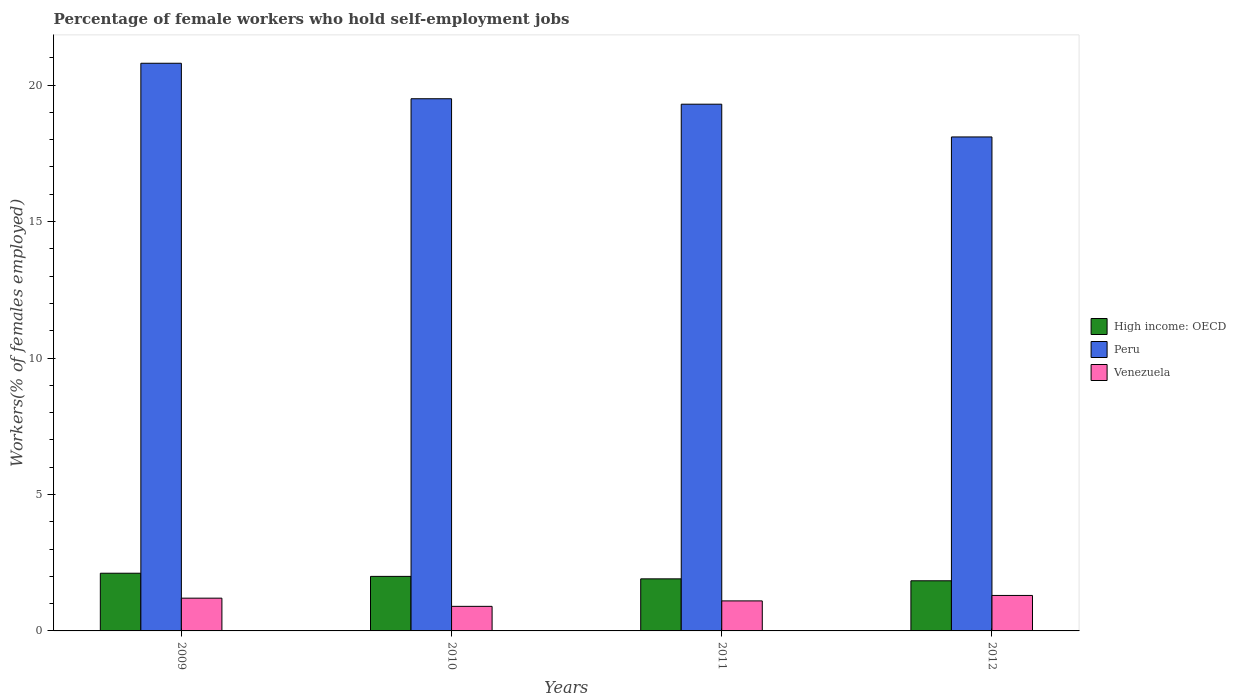Are the number of bars per tick equal to the number of legend labels?
Offer a terse response. Yes. Are the number of bars on each tick of the X-axis equal?
Offer a very short reply. Yes. How many bars are there on the 1st tick from the left?
Provide a succinct answer. 3. What is the percentage of self-employed female workers in High income: OECD in 2012?
Ensure brevity in your answer.  1.84. Across all years, what is the maximum percentage of self-employed female workers in Venezuela?
Provide a succinct answer. 1.3. Across all years, what is the minimum percentage of self-employed female workers in Venezuela?
Ensure brevity in your answer.  0.9. What is the total percentage of self-employed female workers in High income: OECD in the graph?
Your answer should be very brief. 7.86. What is the difference between the percentage of self-employed female workers in Peru in 2009 and that in 2012?
Your response must be concise. 2.7. What is the difference between the percentage of self-employed female workers in Venezuela in 2010 and the percentage of self-employed female workers in High income: OECD in 2012?
Ensure brevity in your answer.  -0.94. What is the average percentage of self-employed female workers in High income: OECD per year?
Provide a succinct answer. 1.96. In the year 2009, what is the difference between the percentage of self-employed female workers in High income: OECD and percentage of self-employed female workers in Venezuela?
Offer a terse response. 0.91. What is the ratio of the percentage of self-employed female workers in Peru in 2009 to that in 2011?
Provide a succinct answer. 1.08. Is the percentage of self-employed female workers in Venezuela in 2009 less than that in 2011?
Offer a terse response. No. Is the difference between the percentage of self-employed female workers in High income: OECD in 2009 and 2012 greater than the difference between the percentage of self-employed female workers in Venezuela in 2009 and 2012?
Your response must be concise. Yes. What is the difference between the highest and the second highest percentage of self-employed female workers in Peru?
Offer a terse response. 1.3. What is the difference between the highest and the lowest percentage of self-employed female workers in High income: OECD?
Provide a succinct answer. 0.28. In how many years, is the percentage of self-employed female workers in High income: OECD greater than the average percentage of self-employed female workers in High income: OECD taken over all years?
Ensure brevity in your answer.  2. Is the sum of the percentage of self-employed female workers in Peru in 2011 and 2012 greater than the maximum percentage of self-employed female workers in High income: OECD across all years?
Give a very brief answer. Yes. Is it the case that in every year, the sum of the percentage of self-employed female workers in High income: OECD and percentage of self-employed female workers in Peru is greater than the percentage of self-employed female workers in Venezuela?
Ensure brevity in your answer.  Yes. Are the values on the major ticks of Y-axis written in scientific E-notation?
Make the answer very short. No. Where does the legend appear in the graph?
Make the answer very short. Center right. How many legend labels are there?
Keep it short and to the point. 3. What is the title of the graph?
Your answer should be compact. Percentage of female workers who hold self-employment jobs. What is the label or title of the Y-axis?
Your answer should be compact. Workers(% of females employed). What is the Workers(% of females employed) of High income: OECD in 2009?
Offer a very short reply. 2.11. What is the Workers(% of females employed) in Peru in 2009?
Provide a short and direct response. 20.8. What is the Workers(% of females employed) in Venezuela in 2009?
Give a very brief answer. 1.2. What is the Workers(% of females employed) in High income: OECD in 2010?
Give a very brief answer. 2. What is the Workers(% of females employed) of Venezuela in 2010?
Ensure brevity in your answer.  0.9. What is the Workers(% of females employed) in High income: OECD in 2011?
Your answer should be very brief. 1.91. What is the Workers(% of females employed) in Peru in 2011?
Provide a succinct answer. 19.3. What is the Workers(% of females employed) of Venezuela in 2011?
Your answer should be very brief. 1.1. What is the Workers(% of females employed) of High income: OECD in 2012?
Ensure brevity in your answer.  1.84. What is the Workers(% of females employed) of Peru in 2012?
Keep it short and to the point. 18.1. What is the Workers(% of females employed) of Venezuela in 2012?
Your response must be concise. 1.3. Across all years, what is the maximum Workers(% of females employed) of High income: OECD?
Your answer should be very brief. 2.11. Across all years, what is the maximum Workers(% of females employed) in Peru?
Offer a terse response. 20.8. Across all years, what is the maximum Workers(% of females employed) of Venezuela?
Make the answer very short. 1.3. Across all years, what is the minimum Workers(% of females employed) of High income: OECD?
Keep it short and to the point. 1.84. Across all years, what is the minimum Workers(% of females employed) in Peru?
Keep it short and to the point. 18.1. Across all years, what is the minimum Workers(% of females employed) in Venezuela?
Make the answer very short. 0.9. What is the total Workers(% of females employed) in High income: OECD in the graph?
Offer a very short reply. 7.86. What is the total Workers(% of females employed) in Peru in the graph?
Your answer should be compact. 77.7. What is the total Workers(% of females employed) of Venezuela in the graph?
Offer a terse response. 4.5. What is the difference between the Workers(% of females employed) in High income: OECD in 2009 and that in 2010?
Provide a succinct answer. 0.12. What is the difference between the Workers(% of females employed) of High income: OECD in 2009 and that in 2011?
Ensure brevity in your answer.  0.21. What is the difference between the Workers(% of females employed) of Venezuela in 2009 and that in 2011?
Your answer should be very brief. 0.1. What is the difference between the Workers(% of females employed) of High income: OECD in 2009 and that in 2012?
Give a very brief answer. 0.28. What is the difference between the Workers(% of females employed) in Peru in 2009 and that in 2012?
Offer a terse response. 2.7. What is the difference between the Workers(% of females employed) in High income: OECD in 2010 and that in 2011?
Your answer should be compact. 0.09. What is the difference between the Workers(% of females employed) of Peru in 2010 and that in 2011?
Give a very brief answer. 0.2. What is the difference between the Workers(% of females employed) of Venezuela in 2010 and that in 2011?
Provide a short and direct response. -0.2. What is the difference between the Workers(% of females employed) in High income: OECD in 2010 and that in 2012?
Keep it short and to the point. 0.16. What is the difference between the Workers(% of females employed) of High income: OECD in 2011 and that in 2012?
Your response must be concise. 0.07. What is the difference between the Workers(% of females employed) in Venezuela in 2011 and that in 2012?
Provide a short and direct response. -0.2. What is the difference between the Workers(% of females employed) in High income: OECD in 2009 and the Workers(% of females employed) in Peru in 2010?
Ensure brevity in your answer.  -17.39. What is the difference between the Workers(% of females employed) in High income: OECD in 2009 and the Workers(% of females employed) in Venezuela in 2010?
Offer a very short reply. 1.21. What is the difference between the Workers(% of females employed) in Peru in 2009 and the Workers(% of females employed) in Venezuela in 2010?
Your answer should be very brief. 19.9. What is the difference between the Workers(% of females employed) in High income: OECD in 2009 and the Workers(% of females employed) in Peru in 2011?
Provide a short and direct response. -17.19. What is the difference between the Workers(% of females employed) in High income: OECD in 2009 and the Workers(% of females employed) in Venezuela in 2011?
Your answer should be compact. 1.01. What is the difference between the Workers(% of females employed) of High income: OECD in 2009 and the Workers(% of females employed) of Peru in 2012?
Keep it short and to the point. -15.99. What is the difference between the Workers(% of females employed) in High income: OECD in 2009 and the Workers(% of females employed) in Venezuela in 2012?
Keep it short and to the point. 0.81. What is the difference between the Workers(% of females employed) of High income: OECD in 2010 and the Workers(% of females employed) of Peru in 2011?
Make the answer very short. -17.3. What is the difference between the Workers(% of females employed) of High income: OECD in 2010 and the Workers(% of females employed) of Venezuela in 2011?
Your answer should be very brief. 0.9. What is the difference between the Workers(% of females employed) of High income: OECD in 2010 and the Workers(% of females employed) of Peru in 2012?
Provide a short and direct response. -16.1. What is the difference between the Workers(% of females employed) of High income: OECD in 2010 and the Workers(% of females employed) of Venezuela in 2012?
Your answer should be compact. 0.7. What is the difference between the Workers(% of females employed) of High income: OECD in 2011 and the Workers(% of females employed) of Peru in 2012?
Your answer should be very brief. -16.19. What is the difference between the Workers(% of females employed) of High income: OECD in 2011 and the Workers(% of females employed) of Venezuela in 2012?
Your answer should be very brief. 0.61. What is the average Workers(% of females employed) of High income: OECD per year?
Your answer should be compact. 1.96. What is the average Workers(% of females employed) of Peru per year?
Your response must be concise. 19.43. In the year 2009, what is the difference between the Workers(% of females employed) in High income: OECD and Workers(% of females employed) in Peru?
Your answer should be compact. -18.69. In the year 2009, what is the difference between the Workers(% of females employed) in High income: OECD and Workers(% of females employed) in Venezuela?
Ensure brevity in your answer.  0.91. In the year 2009, what is the difference between the Workers(% of females employed) in Peru and Workers(% of females employed) in Venezuela?
Your answer should be compact. 19.6. In the year 2010, what is the difference between the Workers(% of females employed) of High income: OECD and Workers(% of females employed) of Peru?
Provide a succinct answer. -17.5. In the year 2010, what is the difference between the Workers(% of females employed) of High income: OECD and Workers(% of females employed) of Venezuela?
Make the answer very short. 1.1. In the year 2010, what is the difference between the Workers(% of females employed) in Peru and Workers(% of females employed) in Venezuela?
Keep it short and to the point. 18.6. In the year 2011, what is the difference between the Workers(% of females employed) of High income: OECD and Workers(% of females employed) of Peru?
Offer a very short reply. -17.39. In the year 2011, what is the difference between the Workers(% of females employed) in High income: OECD and Workers(% of females employed) in Venezuela?
Provide a short and direct response. 0.81. In the year 2012, what is the difference between the Workers(% of females employed) in High income: OECD and Workers(% of females employed) in Peru?
Your answer should be very brief. -16.26. In the year 2012, what is the difference between the Workers(% of females employed) in High income: OECD and Workers(% of females employed) in Venezuela?
Keep it short and to the point. 0.54. What is the ratio of the Workers(% of females employed) in High income: OECD in 2009 to that in 2010?
Offer a very short reply. 1.06. What is the ratio of the Workers(% of females employed) in Peru in 2009 to that in 2010?
Your response must be concise. 1.07. What is the ratio of the Workers(% of females employed) of High income: OECD in 2009 to that in 2011?
Offer a terse response. 1.11. What is the ratio of the Workers(% of females employed) of Peru in 2009 to that in 2011?
Provide a succinct answer. 1.08. What is the ratio of the Workers(% of females employed) in Venezuela in 2009 to that in 2011?
Give a very brief answer. 1.09. What is the ratio of the Workers(% of females employed) of High income: OECD in 2009 to that in 2012?
Provide a succinct answer. 1.15. What is the ratio of the Workers(% of females employed) of Peru in 2009 to that in 2012?
Your answer should be compact. 1.15. What is the ratio of the Workers(% of females employed) of High income: OECD in 2010 to that in 2011?
Your answer should be very brief. 1.05. What is the ratio of the Workers(% of females employed) in Peru in 2010 to that in 2011?
Your answer should be compact. 1.01. What is the ratio of the Workers(% of females employed) in Venezuela in 2010 to that in 2011?
Your response must be concise. 0.82. What is the ratio of the Workers(% of females employed) of High income: OECD in 2010 to that in 2012?
Your answer should be very brief. 1.09. What is the ratio of the Workers(% of females employed) of Peru in 2010 to that in 2012?
Your answer should be very brief. 1.08. What is the ratio of the Workers(% of females employed) in Venezuela in 2010 to that in 2012?
Your response must be concise. 0.69. What is the ratio of the Workers(% of females employed) of High income: OECD in 2011 to that in 2012?
Your answer should be compact. 1.04. What is the ratio of the Workers(% of females employed) in Peru in 2011 to that in 2012?
Provide a short and direct response. 1.07. What is the ratio of the Workers(% of females employed) of Venezuela in 2011 to that in 2012?
Offer a terse response. 0.85. What is the difference between the highest and the second highest Workers(% of females employed) in High income: OECD?
Offer a very short reply. 0.12. What is the difference between the highest and the second highest Workers(% of females employed) in Peru?
Keep it short and to the point. 1.3. What is the difference between the highest and the second highest Workers(% of females employed) in Venezuela?
Give a very brief answer. 0.1. What is the difference between the highest and the lowest Workers(% of females employed) in High income: OECD?
Your answer should be compact. 0.28. 